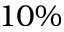<formula> <loc_0><loc_0><loc_500><loc_500>1 0 \%</formula> 